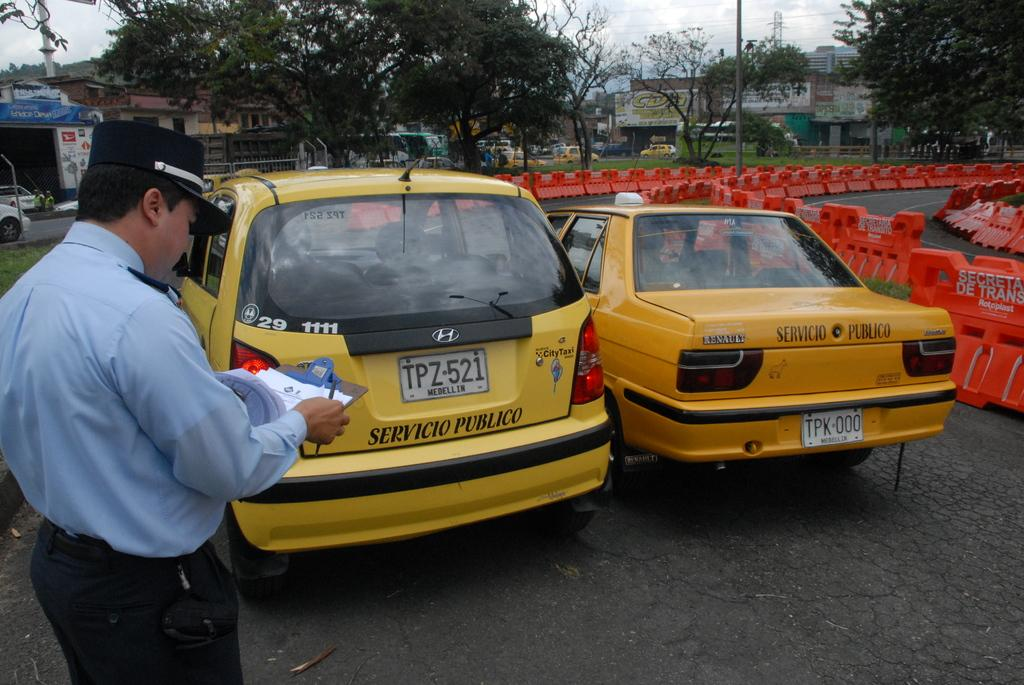<image>
Summarize the visual content of the image. Two yellow taxi cabs apre parked next to each other with the one on the left having the logo for honda on it. 